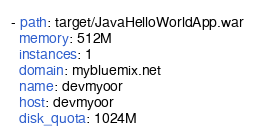Convert code to text. <code><loc_0><loc_0><loc_500><loc_500><_YAML_>- path: target/JavaHelloWorldApp.war
  memory: 512M
  instances: 1
  domain: mybluemix.net
  name: devmyoor
  host: devmyoor
  disk_quota: 1024M
</code> 